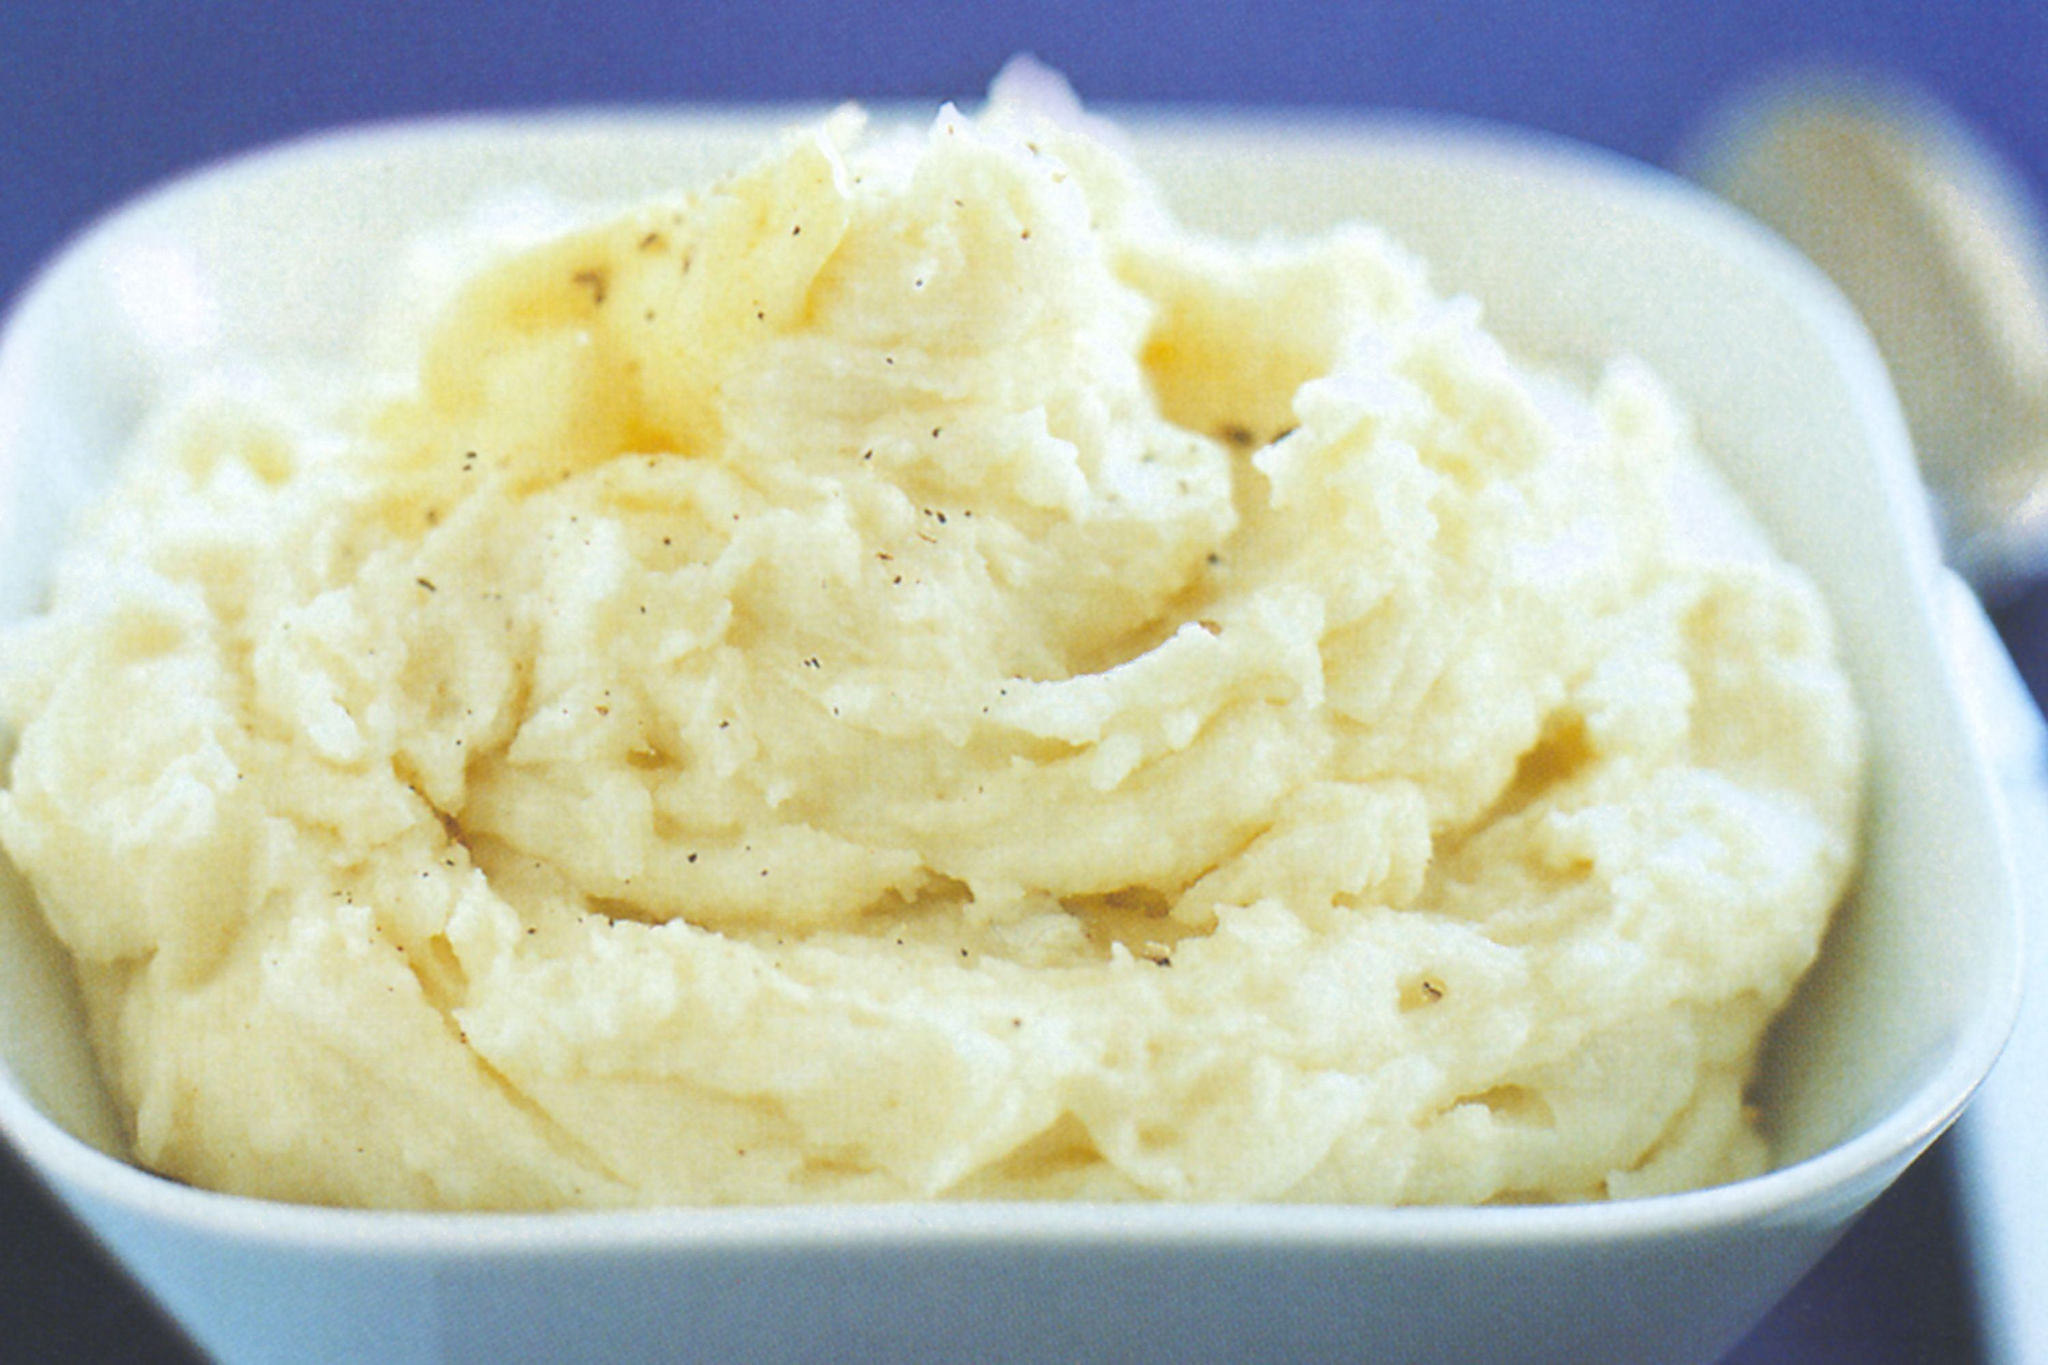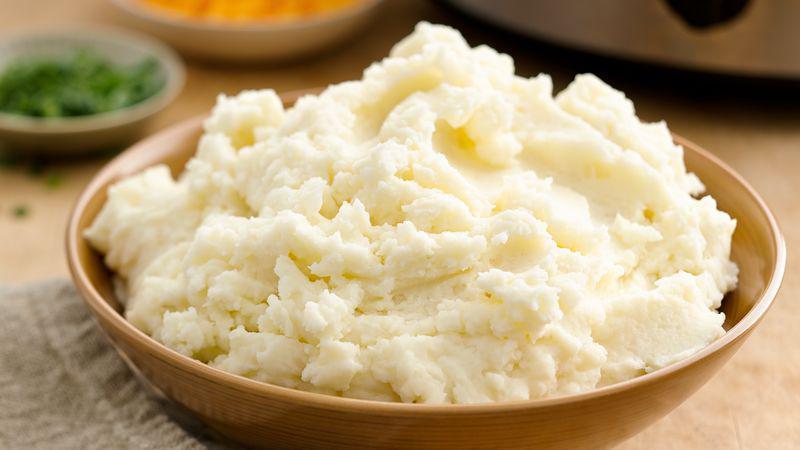The first image is the image on the left, the second image is the image on the right. Assess this claim about the two images: "The dish on the right contains a large piece of green garnish.". Correct or not? Answer yes or no. No. The first image is the image on the left, the second image is the image on the right. Examine the images to the left and right. Is the description "At least one bowl is white." accurate? Answer yes or no. Yes. The first image is the image on the left, the second image is the image on the right. For the images displayed, is the sentence "An image shows a bowl of mashed potatoes garnished with one green sprig." factually correct? Answer yes or no. No. 